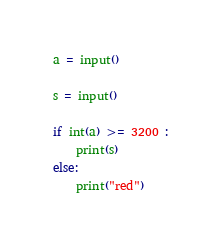Convert code to text. <code><loc_0><loc_0><loc_500><loc_500><_Python_>
a = input()

s = input()

if int(a) >= 3200 :
    print(s)
else:
    print("red")</code> 